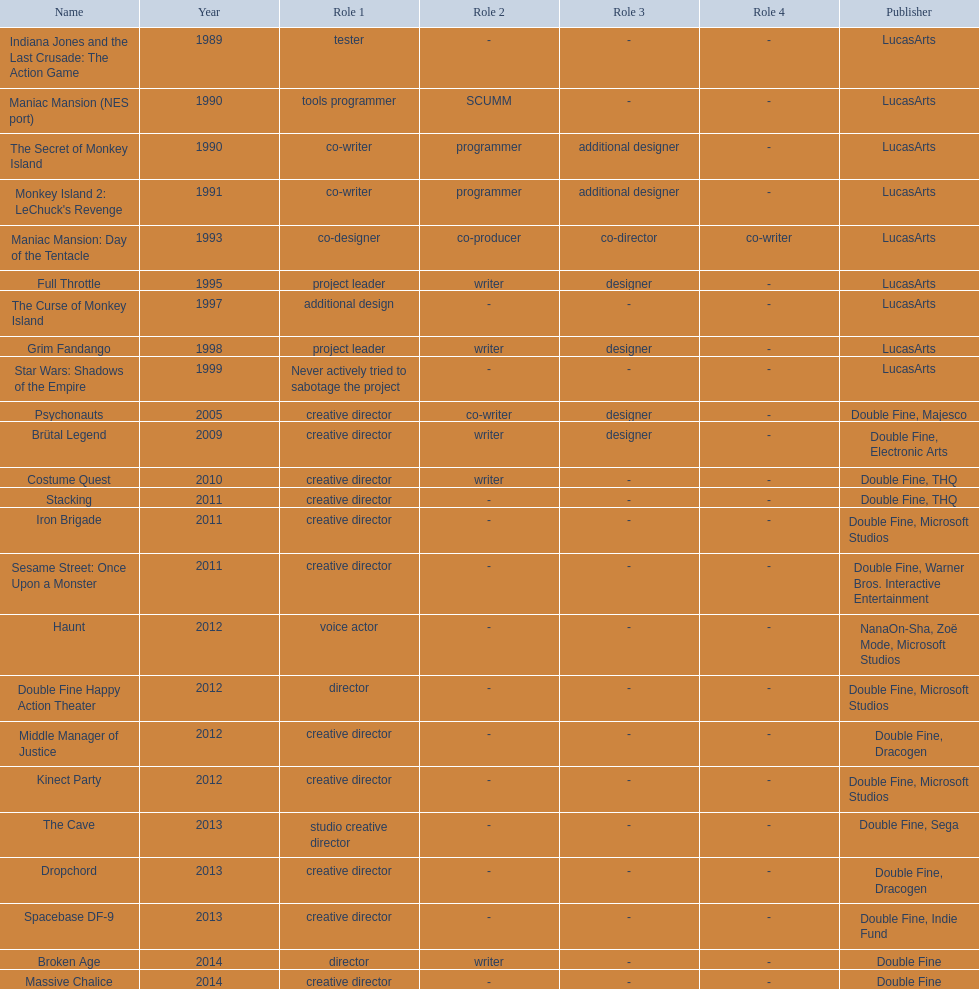I'm looking to parse the entire table for insights. Could you assist me with that? {'header': ['Name', 'Year', 'Role 1', 'Role 2', 'Role 3', 'Role 4', 'Publisher'], 'rows': [['Indiana Jones and the Last Crusade: The Action Game', '1989', 'tester', '-', '-', '-', 'LucasArts'], ['Maniac Mansion (NES port)', '1990', 'tools programmer', 'SCUMM', '-', '-', 'LucasArts'], ['The Secret of Monkey Island', '1990', 'co-writer', 'programmer', 'additional designer', '-', 'LucasArts'], ["Monkey Island 2: LeChuck's Revenge", '1991', 'co-writer', 'programmer', 'additional designer', '-', 'LucasArts'], ['Maniac Mansion: Day of the Tentacle', '1993', 'co-designer', 'co-producer', 'co-director', 'co-writer', 'LucasArts'], ['Full Throttle', '1995', 'project leader', 'writer', 'designer', '-', 'LucasArts'], ['The Curse of Monkey Island', '1997', 'additional design', '-', '-', '-', 'LucasArts'], ['Grim Fandango', '1998', 'project leader', 'writer', 'designer', '-', 'LucasArts'], ['Star Wars: Shadows of the Empire', '1999', 'Never actively tried to sabotage the project', '-', '-', '-', 'LucasArts'], ['Psychonauts', '2005', 'creative director', 'co-writer', 'designer', '-', 'Double Fine, Majesco'], ['Brütal Legend', '2009', 'creative director', 'writer', 'designer', '-', 'Double Fine, Electronic Arts'], ['Costume Quest', '2010', 'creative director', 'writer', '-', '-', 'Double Fine, THQ'], ['Stacking', '2011', 'creative director', '-', '-', '-', 'Double Fine, THQ'], ['Iron Brigade', '2011', 'creative director', '-', '-', '-', 'Double Fine, Microsoft Studios'], ['Sesame Street: Once Upon a Monster', '2011', 'creative director', '-', '-', '-', 'Double Fine, Warner Bros. Interactive Entertainment'], ['Haunt', '2012', 'voice actor', '-', '-', '-', 'NanaOn-Sha, Zoë Mode, Microsoft Studios'], ['Double Fine Happy Action Theater', '2012', 'director', '-', '-', '-', 'Double Fine, Microsoft Studios'], ['Middle Manager of Justice', '2012', 'creative director', '-', '-', '-', 'Double Fine, Dracogen'], ['Kinect Party', '2012', 'creative director', '-', '-', '-', 'Double Fine, Microsoft Studios'], ['The Cave', '2013', 'studio creative director', '-', '-', '-', 'Double Fine, Sega'], ['Dropchord', '2013', 'creative director', '-', '-', '-', 'Double Fine, Dracogen'], ['Spacebase DF-9', '2013', 'creative director', '-', '-', '-', 'Double Fine, Indie Fund'], ['Broken Age', '2014', 'director', 'writer', '-', '-', 'Double Fine'], ['Massive Chalice', '2014', 'creative director', '-', '-', '-', 'Double Fine']]} Which game is credited with a creative director? Creative director, co-writer, designer, creative director, writer, designer, creative director, writer, creative director, creative director, creative director, creative director, creative director, creative director, creative director, creative director. Of these games, which also has warner bros. interactive listed as creative director? Sesame Street: Once Upon a Monster. 